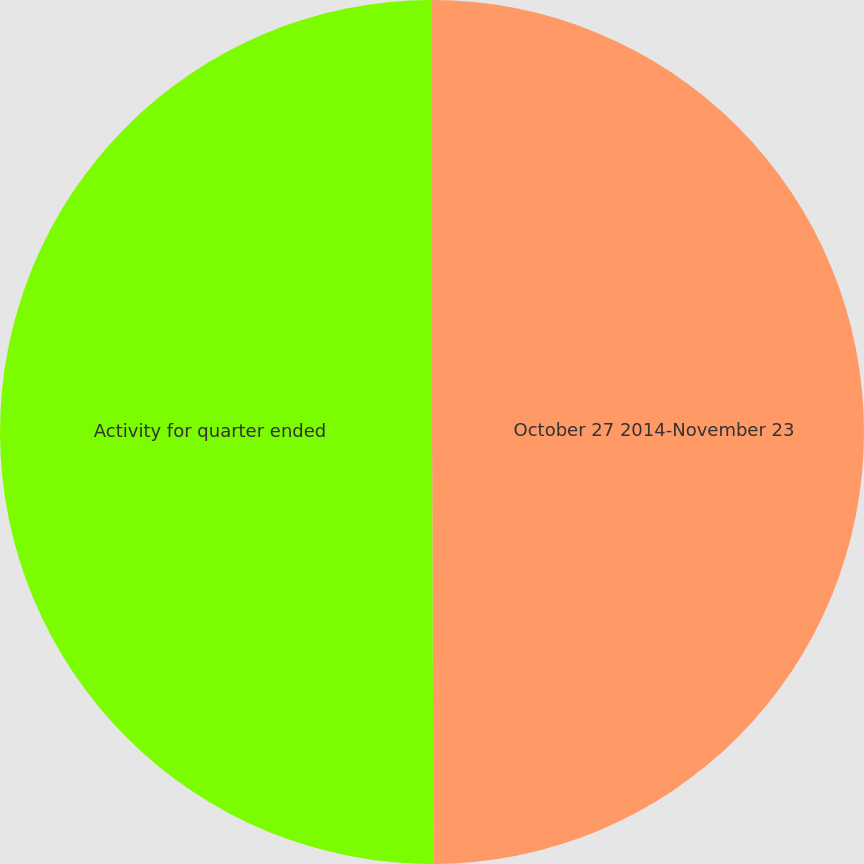Convert chart. <chart><loc_0><loc_0><loc_500><loc_500><pie_chart><fcel>October 27 2014-November 23<fcel>Activity for quarter ended<nl><fcel>49.94%<fcel>50.06%<nl></chart> 